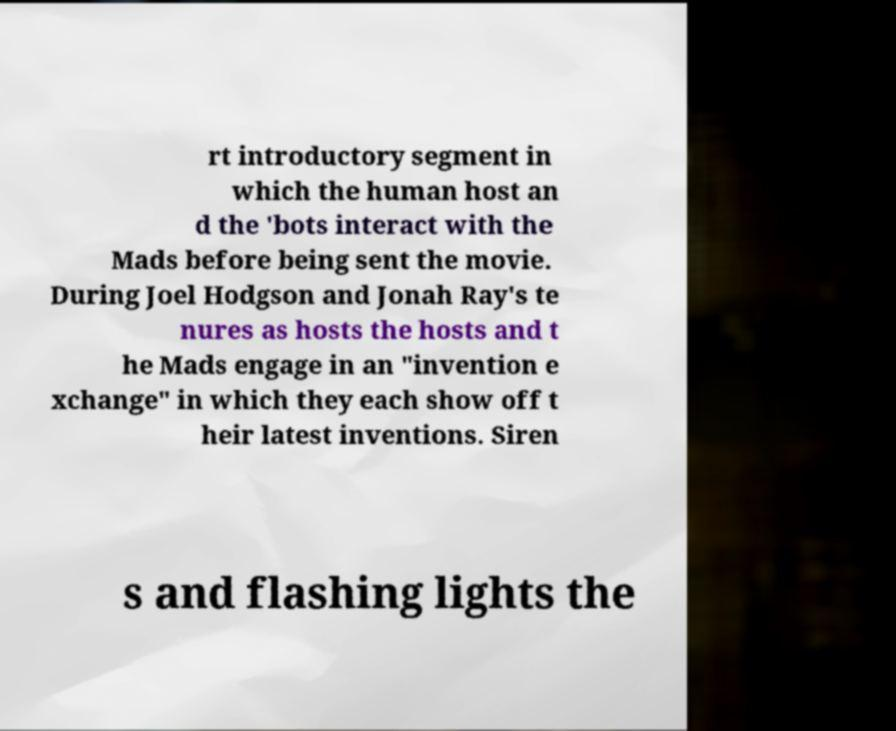Could you assist in decoding the text presented in this image and type it out clearly? rt introductory segment in which the human host an d the 'bots interact with the Mads before being sent the movie. During Joel Hodgson and Jonah Ray's te nures as hosts the hosts and t he Mads engage in an "invention e xchange" in which they each show off t heir latest inventions. Siren s and flashing lights the 